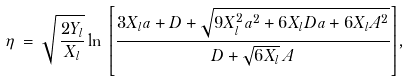Convert formula to latex. <formula><loc_0><loc_0><loc_500><loc_500>\eta \, = \, \sqrt { \, \frac { 2 Y _ { l } } { X _ { l } } } \ln \, { \left [ \frac { 3 X _ { l } a + D + \sqrt { 9 X _ { l } ^ { 2 } a ^ { 2 } + 6 X _ { l } D a + 6 X _ { l } A ^ { 2 } } } { D + \sqrt { 6 X _ { l } } \, A } \right ] } ,</formula> 